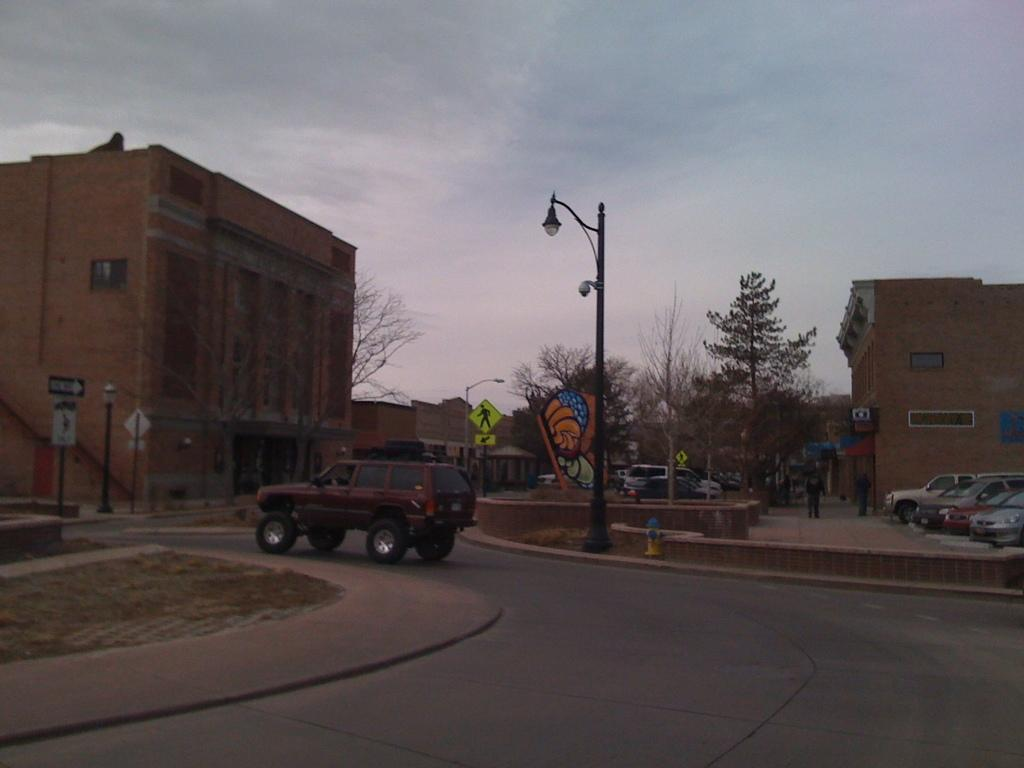What is the main feature of the image? There is a road in the image. What is happening on the road? There are vehicles on the road. What else can be seen in the image besides the road and vehicles? There are buildings, trees, street lights, and the sky visible in the image. Where are the babies playing in the image? There are no babies present in the image. What type of attack is happening in the image? There is no attack happening in the image; it features a road with vehicles and other elements. 